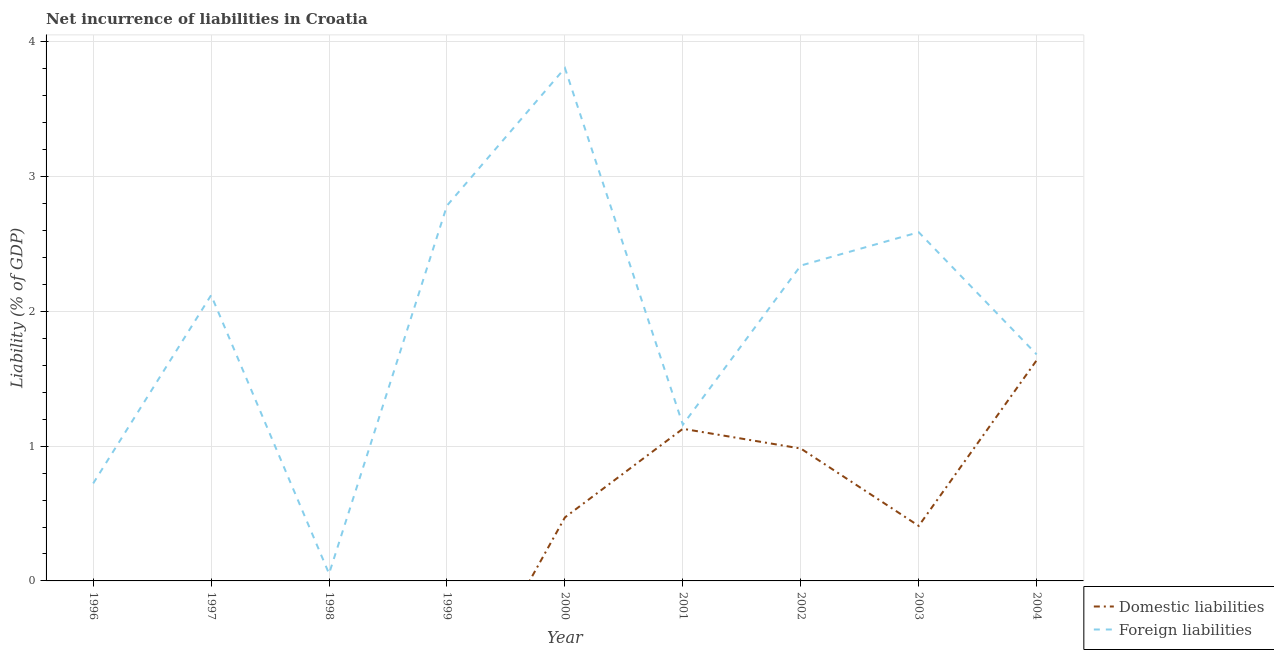How many different coloured lines are there?
Your answer should be compact. 2. What is the incurrence of domestic liabilities in 2004?
Offer a very short reply. 1.64. Across all years, what is the maximum incurrence of foreign liabilities?
Your answer should be compact. 3.81. Across all years, what is the minimum incurrence of domestic liabilities?
Ensure brevity in your answer.  0. In which year was the incurrence of foreign liabilities maximum?
Make the answer very short. 2000. What is the total incurrence of domestic liabilities in the graph?
Give a very brief answer. 4.63. What is the difference between the incurrence of foreign liabilities in 1997 and that in 2002?
Provide a succinct answer. -0.22. What is the difference between the incurrence of foreign liabilities in 2003 and the incurrence of domestic liabilities in 1997?
Your response must be concise. 2.59. What is the average incurrence of foreign liabilities per year?
Give a very brief answer. 1.92. In the year 2003, what is the difference between the incurrence of domestic liabilities and incurrence of foreign liabilities?
Give a very brief answer. -2.18. What is the ratio of the incurrence of foreign liabilities in 1997 to that in 2004?
Give a very brief answer. 1.26. What is the difference between the highest and the second highest incurrence of domestic liabilities?
Offer a terse response. 0.51. What is the difference between the highest and the lowest incurrence of domestic liabilities?
Keep it short and to the point. 1.64. In how many years, is the incurrence of foreign liabilities greater than the average incurrence of foreign liabilities taken over all years?
Provide a short and direct response. 5. Is the sum of the incurrence of domestic liabilities in 2002 and 2003 greater than the maximum incurrence of foreign liabilities across all years?
Keep it short and to the point. No. How many years are there in the graph?
Your answer should be compact. 9. What is the difference between two consecutive major ticks on the Y-axis?
Your answer should be very brief. 1. Are the values on the major ticks of Y-axis written in scientific E-notation?
Ensure brevity in your answer.  No. Does the graph contain any zero values?
Give a very brief answer. Yes. Where does the legend appear in the graph?
Offer a very short reply. Bottom right. How are the legend labels stacked?
Offer a terse response. Vertical. What is the title of the graph?
Provide a succinct answer. Net incurrence of liabilities in Croatia. Does "Diesel" appear as one of the legend labels in the graph?
Your response must be concise. No. What is the label or title of the X-axis?
Your answer should be compact. Year. What is the label or title of the Y-axis?
Your answer should be compact. Liability (% of GDP). What is the Liability (% of GDP) in Foreign liabilities in 1996?
Provide a short and direct response. 0.72. What is the Liability (% of GDP) of Foreign liabilities in 1997?
Make the answer very short. 2.12. What is the Liability (% of GDP) of Domestic liabilities in 1998?
Provide a succinct answer. 0. What is the Liability (% of GDP) of Foreign liabilities in 1998?
Give a very brief answer. 0.05. What is the Liability (% of GDP) of Domestic liabilities in 1999?
Make the answer very short. 0. What is the Liability (% of GDP) in Foreign liabilities in 1999?
Offer a terse response. 2.78. What is the Liability (% of GDP) in Domestic liabilities in 2000?
Ensure brevity in your answer.  0.47. What is the Liability (% of GDP) of Foreign liabilities in 2000?
Ensure brevity in your answer.  3.81. What is the Liability (% of GDP) in Domestic liabilities in 2001?
Keep it short and to the point. 1.13. What is the Liability (% of GDP) of Foreign liabilities in 2001?
Your answer should be very brief. 1.16. What is the Liability (% of GDP) in Domestic liabilities in 2002?
Offer a very short reply. 0.98. What is the Liability (% of GDP) in Foreign liabilities in 2002?
Provide a succinct answer. 2.34. What is the Liability (% of GDP) in Domestic liabilities in 2003?
Give a very brief answer. 0.41. What is the Liability (% of GDP) of Foreign liabilities in 2003?
Provide a short and direct response. 2.59. What is the Liability (% of GDP) in Domestic liabilities in 2004?
Your response must be concise. 1.64. What is the Liability (% of GDP) of Foreign liabilities in 2004?
Make the answer very short. 1.68. Across all years, what is the maximum Liability (% of GDP) of Domestic liabilities?
Give a very brief answer. 1.64. Across all years, what is the maximum Liability (% of GDP) in Foreign liabilities?
Offer a very short reply. 3.81. Across all years, what is the minimum Liability (% of GDP) of Domestic liabilities?
Give a very brief answer. 0. Across all years, what is the minimum Liability (% of GDP) of Foreign liabilities?
Provide a succinct answer. 0.05. What is the total Liability (% of GDP) in Domestic liabilities in the graph?
Make the answer very short. 4.63. What is the total Liability (% of GDP) in Foreign liabilities in the graph?
Make the answer very short. 17.26. What is the difference between the Liability (% of GDP) in Foreign liabilities in 1996 and that in 1997?
Ensure brevity in your answer.  -1.4. What is the difference between the Liability (% of GDP) in Foreign liabilities in 1996 and that in 1998?
Keep it short and to the point. 0.67. What is the difference between the Liability (% of GDP) in Foreign liabilities in 1996 and that in 1999?
Your response must be concise. -2.06. What is the difference between the Liability (% of GDP) in Foreign liabilities in 1996 and that in 2000?
Keep it short and to the point. -3.08. What is the difference between the Liability (% of GDP) in Foreign liabilities in 1996 and that in 2001?
Your answer should be very brief. -0.44. What is the difference between the Liability (% of GDP) in Foreign liabilities in 1996 and that in 2002?
Provide a short and direct response. -1.62. What is the difference between the Liability (% of GDP) of Foreign liabilities in 1996 and that in 2003?
Offer a terse response. -1.86. What is the difference between the Liability (% of GDP) of Foreign liabilities in 1996 and that in 2004?
Keep it short and to the point. -0.96. What is the difference between the Liability (% of GDP) of Foreign liabilities in 1997 and that in 1998?
Your response must be concise. 2.07. What is the difference between the Liability (% of GDP) of Foreign liabilities in 1997 and that in 1999?
Your response must be concise. -0.66. What is the difference between the Liability (% of GDP) in Foreign liabilities in 1997 and that in 2000?
Give a very brief answer. -1.69. What is the difference between the Liability (% of GDP) of Foreign liabilities in 1997 and that in 2001?
Provide a succinct answer. 0.96. What is the difference between the Liability (% of GDP) in Foreign liabilities in 1997 and that in 2002?
Offer a very short reply. -0.22. What is the difference between the Liability (% of GDP) in Foreign liabilities in 1997 and that in 2003?
Your answer should be compact. -0.47. What is the difference between the Liability (% of GDP) of Foreign liabilities in 1997 and that in 2004?
Offer a very short reply. 0.44. What is the difference between the Liability (% of GDP) in Foreign liabilities in 1998 and that in 1999?
Offer a very short reply. -2.73. What is the difference between the Liability (% of GDP) in Foreign liabilities in 1998 and that in 2000?
Offer a terse response. -3.75. What is the difference between the Liability (% of GDP) in Foreign liabilities in 1998 and that in 2001?
Your answer should be compact. -1.11. What is the difference between the Liability (% of GDP) in Foreign liabilities in 1998 and that in 2002?
Keep it short and to the point. -2.29. What is the difference between the Liability (% of GDP) of Foreign liabilities in 1998 and that in 2003?
Make the answer very short. -2.53. What is the difference between the Liability (% of GDP) in Foreign liabilities in 1998 and that in 2004?
Your answer should be very brief. -1.63. What is the difference between the Liability (% of GDP) of Foreign liabilities in 1999 and that in 2000?
Ensure brevity in your answer.  -1.02. What is the difference between the Liability (% of GDP) of Foreign liabilities in 1999 and that in 2001?
Offer a very short reply. 1.63. What is the difference between the Liability (% of GDP) in Foreign liabilities in 1999 and that in 2002?
Provide a succinct answer. 0.44. What is the difference between the Liability (% of GDP) of Foreign liabilities in 1999 and that in 2003?
Your answer should be compact. 0.2. What is the difference between the Liability (% of GDP) of Foreign liabilities in 1999 and that in 2004?
Your response must be concise. 1.1. What is the difference between the Liability (% of GDP) in Domestic liabilities in 2000 and that in 2001?
Your answer should be very brief. -0.66. What is the difference between the Liability (% of GDP) in Foreign liabilities in 2000 and that in 2001?
Offer a very short reply. 2.65. What is the difference between the Liability (% of GDP) of Domestic liabilities in 2000 and that in 2002?
Provide a succinct answer. -0.51. What is the difference between the Liability (% of GDP) of Foreign liabilities in 2000 and that in 2002?
Provide a short and direct response. 1.47. What is the difference between the Liability (% of GDP) in Domestic liabilities in 2000 and that in 2003?
Provide a succinct answer. 0.06. What is the difference between the Liability (% of GDP) of Foreign liabilities in 2000 and that in 2003?
Offer a very short reply. 1.22. What is the difference between the Liability (% of GDP) in Domestic liabilities in 2000 and that in 2004?
Ensure brevity in your answer.  -1.17. What is the difference between the Liability (% of GDP) of Foreign liabilities in 2000 and that in 2004?
Offer a very short reply. 2.12. What is the difference between the Liability (% of GDP) of Domestic liabilities in 2001 and that in 2002?
Your answer should be compact. 0.15. What is the difference between the Liability (% of GDP) in Foreign liabilities in 2001 and that in 2002?
Offer a terse response. -1.18. What is the difference between the Liability (% of GDP) of Domestic liabilities in 2001 and that in 2003?
Keep it short and to the point. 0.72. What is the difference between the Liability (% of GDP) in Foreign liabilities in 2001 and that in 2003?
Your answer should be very brief. -1.43. What is the difference between the Liability (% of GDP) of Domestic liabilities in 2001 and that in 2004?
Provide a succinct answer. -0.51. What is the difference between the Liability (% of GDP) of Foreign liabilities in 2001 and that in 2004?
Your response must be concise. -0.52. What is the difference between the Liability (% of GDP) in Domestic liabilities in 2002 and that in 2003?
Your answer should be compact. 0.57. What is the difference between the Liability (% of GDP) in Foreign liabilities in 2002 and that in 2003?
Your answer should be compact. -0.25. What is the difference between the Liability (% of GDP) in Domestic liabilities in 2002 and that in 2004?
Provide a short and direct response. -0.65. What is the difference between the Liability (% of GDP) in Foreign liabilities in 2002 and that in 2004?
Provide a succinct answer. 0.66. What is the difference between the Liability (% of GDP) in Domestic liabilities in 2003 and that in 2004?
Provide a succinct answer. -1.23. What is the difference between the Liability (% of GDP) of Foreign liabilities in 2003 and that in 2004?
Ensure brevity in your answer.  0.91. What is the difference between the Liability (% of GDP) of Domestic liabilities in 2000 and the Liability (% of GDP) of Foreign liabilities in 2001?
Offer a terse response. -0.69. What is the difference between the Liability (% of GDP) in Domestic liabilities in 2000 and the Liability (% of GDP) in Foreign liabilities in 2002?
Make the answer very short. -1.87. What is the difference between the Liability (% of GDP) of Domestic liabilities in 2000 and the Liability (% of GDP) of Foreign liabilities in 2003?
Provide a short and direct response. -2.12. What is the difference between the Liability (% of GDP) of Domestic liabilities in 2000 and the Liability (% of GDP) of Foreign liabilities in 2004?
Offer a very short reply. -1.21. What is the difference between the Liability (% of GDP) of Domestic liabilities in 2001 and the Liability (% of GDP) of Foreign liabilities in 2002?
Offer a terse response. -1.21. What is the difference between the Liability (% of GDP) of Domestic liabilities in 2001 and the Liability (% of GDP) of Foreign liabilities in 2003?
Your answer should be compact. -1.46. What is the difference between the Liability (% of GDP) of Domestic liabilities in 2001 and the Liability (% of GDP) of Foreign liabilities in 2004?
Your response must be concise. -0.55. What is the difference between the Liability (% of GDP) of Domestic liabilities in 2002 and the Liability (% of GDP) of Foreign liabilities in 2003?
Offer a very short reply. -1.6. What is the difference between the Liability (% of GDP) in Domestic liabilities in 2002 and the Liability (% of GDP) in Foreign liabilities in 2004?
Your response must be concise. -0.7. What is the difference between the Liability (% of GDP) in Domestic liabilities in 2003 and the Liability (% of GDP) in Foreign liabilities in 2004?
Make the answer very short. -1.27. What is the average Liability (% of GDP) in Domestic liabilities per year?
Offer a terse response. 0.51. What is the average Liability (% of GDP) of Foreign liabilities per year?
Ensure brevity in your answer.  1.92. In the year 2000, what is the difference between the Liability (% of GDP) in Domestic liabilities and Liability (% of GDP) in Foreign liabilities?
Your answer should be very brief. -3.33. In the year 2001, what is the difference between the Liability (% of GDP) of Domestic liabilities and Liability (% of GDP) of Foreign liabilities?
Offer a terse response. -0.03. In the year 2002, what is the difference between the Liability (% of GDP) in Domestic liabilities and Liability (% of GDP) in Foreign liabilities?
Your answer should be very brief. -1.36. In the year 2003, what is the difference between the Liability (% of GDP) of Domestic liabilities and Liability (% of GDP) of Foreign liabilities?
Ensure brevity in your answer.  -2.18. In the year 2004, what is the difference between the Liability (% of GDP) in Domestic liabilities and Liability (% of GDP) in Foreign liabilities?
Give a very brief answer. -0.04. What is the ratio of the Liability (% of GDP) of Foreign liabilities in 1996 to that in 1997?
Offer a terse response. 0.34. What is the ratio of the Liability (% of GDP) in Foreign liabilities in 1996 to that in 1998?
Your answer should be very brief. 13.49. What is the ratio of the Liability (% of GDP) in Foreign liabilities in 1996 to that in 1999?
Ensure brevity in your answer.  0.26. What is the ratio of the Liability (% of GDP) in Foreign liabilities in 1996 to that in 2000?
Ensure brevity in your answer.  0.19. What is the ratio of the Liability (% of GDP) in Foreign liabilities in 1996 to that in 2001?
Make the answer very short. 0.62. What is the ratio of the Liability (% of GDP) in Foreign liabilities in 1996 to that in 2002?
Give a very brief answer. 0.31. What is the ratio of the Liability (% of GDP) of Foreign liabilities in 1996 to that in 2003?
Offer a very short reply. 0.28. What is the ratio of the Liability (% of GDP) of Foreign liabilities in 1996 to that in 2004?
Make the answer very short. 0.43. What is the ratio of the Liability (% of GDP) in Foreign liabilities in 1997 to that in 1998?
Your response must be concise. 39.52. What is the ratio of the Liability (% of GDP) of Foreign liabilities in 1997 to that in 1999?
Offer a very short reply. 0.76. What is the ratio of the Liability (% of GDP) of Foreign liabilities in 1997 to that in 2000?
Give a very brief answer. 0.56. What is the ratio of the Liability (% of GDP) of Foreign liabilities in 1997 to that in 2001?
Your response must be concise. 1.83. What is the ratio of the Liability (% of GDP) of Foreign liabilities in 1997 to that in 2002?
Your answer should be very brief. 0.91. What is the ratio of the Liability (% of GDP) of Foreign liabilities in 1997 to that in 2003?
Your answer should be compact. 0.82. What is the ratio of the Liability (% of GDP) in Foreign liabilities in 1997 to that in 2004?
Your answer should be compact. 1.26. What is the ratio of the Liability (% of GDP) in Foreign liabilities in 1998 to that in 1999?
Your response must be concise. 0.02. What is the ratio of the Liability (% of GDP) in Foreign liabilities in 1998 to that in 2000?
Keep it short and to the point. 0.01. What is the ratio of the Liability (% of GDP) in Foreign liabilities in 1998 to that in 2001?
Provide a succinct answer. 0.05. What is the ratio of the Liability (% of GDP) in Foreign liabilities in 1998 to that in 2002?
Your answer should be very brief. 0.02. What is the ratio of the Liability (% of GDP) in Foreign liabilities in 1998 to that in 2003?
Ensure brevity in your answer.  0.02. What is the ratio of the Liability (% of GDP) of Foreign liabilities in 1998 to that in 2004?
Provide a succinct answer. 0.03. What is the ratio of the Liability (% of GDP) in Foreign liabilities in 1999 to that in 2000?
Keep it short and to the point. 0.73. What is the ratio of the Liability (% of GDP) in Foreign liabilities in 1999 to that in 2001?
Your answer should be very brief. 2.4. What is the ratio of the Liability (% of GDP) in Foreign liabilities in 1999 to that in 2002?
Your answer should be compact. 1.19. What is the ratio of the Liability (% of GDP) in Foreign liabilities in 1999 to that in 2003?
Your response must be concise. 1.08. What is the ratio of the Liability (% of GDP) in Foreign liabilities in 1999 to that in 2004?
Your answer should be very brief. 1.66. What is the ratio of the Liability (% of GDP) in Domestic liabilities in 2000 to that in 2001?
Offer a terse response. 0.42. What is the ratio of the Liability (% of GDP) of Foreign liabilities in 2000 to that in 2001?
Ensure brevity in your answer.  3.28. What is the ratio of the Liability (% of GDP) of Domestic liabilities in 2000 to that in 2002?
Give a very brief answer. 0.48. What is the ratio of the Liability (% of GDP) in Foreign liabilities in 2000 to that in 2002?
Your response must be concise. 1.63. What is the ratio of the Liability (% of GDP) in Domestic liabilities in 2000 to that in 2003?
Offer a terse response. 1.15. What is the ratio of the Liability (% of GDP) in Foreign liabilities in 2000 to that in 2003?
Keep it short and to the point. 1.47. What is the ratio of the Liability (% of GDP) in Domestic liabilities in 2000 to that in 2004?
Your answer should be compact. 0.29. What is the ratio of the Liability (% of GDP) of Foreign liabilities in 2000 to that in 2004?
Your answer should be compact. 2.26. What is the ratio of the Liability (% of GDP) in Domestic liabilities in 2001 to that in 2002?
Make the answer very short. 1.15. What is the ratio of the Liability (% of GDP) in Foreign liabilities in 2001 to that in 2002?
Offer a terse response. 0.5. What is the ratio of the Liability (% of GDP) in Domestic liabilities in 2001 to that in 2003?
Provide a short and direct response. 2.76. What is the ratio of the Liability (% of GDP) in Foreign liabilities in 2001 to that in 2003?
Your answer should be very brief. 0.45. What is the ratio of the Liability (% of GDP) in Domestic liabilities in 2001 to that in 2004?
Provide a succinct answer. 0.69. What is the ratio of the Liability (% of GDP) of Foreign liabilities in 2001 to that in 2004?
Give a very brief answer. 0.69. What is the ratio of the Liability (% of GDP) of Domestic liabilities in 2002 to that in 2003?
Provide a succinct answer. 2.41. What is the ratio of the Liability (% of GDP) in Foreign liabilities in 2002 to that in 2003?
Ensure brevity in your answer.  0.9. What is the ratio of the Liability (% of GDP) of Foreign liabilities in 2002 to that in 2004?
Provide a succinct answer. 1.39. What is the ratio of the Liability (% of GDP) of Domestic liabilities in 2003 to that in 2004?
Offer a terse response. 0.25. What is the ratio of the Liability (% of GDP) of Foreign liabilities in 2003 to that in 2004?
Offer a terse response. 1.54. What is the difference between the highest and the second highest Liability (% of GDP) of Domestic liabilities?
Your answer should be compact. 0.51. What is the difference between the highest and the second highest Liability (% of GDP) in Foreign liabilities?
Give a very brief answer. 1.02. What is the difference between the highest and the lowest Liability (% of GDP) of Domestic liabilities?
Your response must be concise. 1.64. What is the difference between the highest and the lowest Liability (% of GDP) in Foreign liabilities?
Your answer should be very brief. 3.75. 